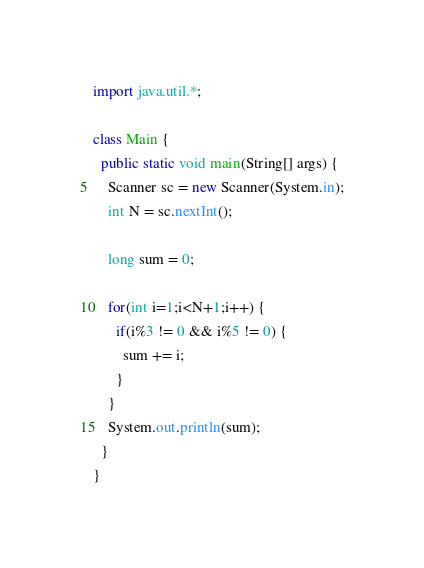Convert code to text. <code><loc_0><loc_0><loc_500><loc_500><_Java_>import java.util.*;
 
class Main {
  public static void main(String[] args) {
    Scanner sc = new Scanner(System.in);
    int N = sc.nextInt();
    
    long sum = 0;
    
    for(int i=1;i<N+1;i++) {
      if(i%3 != 0 && i%5 != 0) {
        sum += i;
      }
    }
    System.out.println(sum);
  }
}</code> 